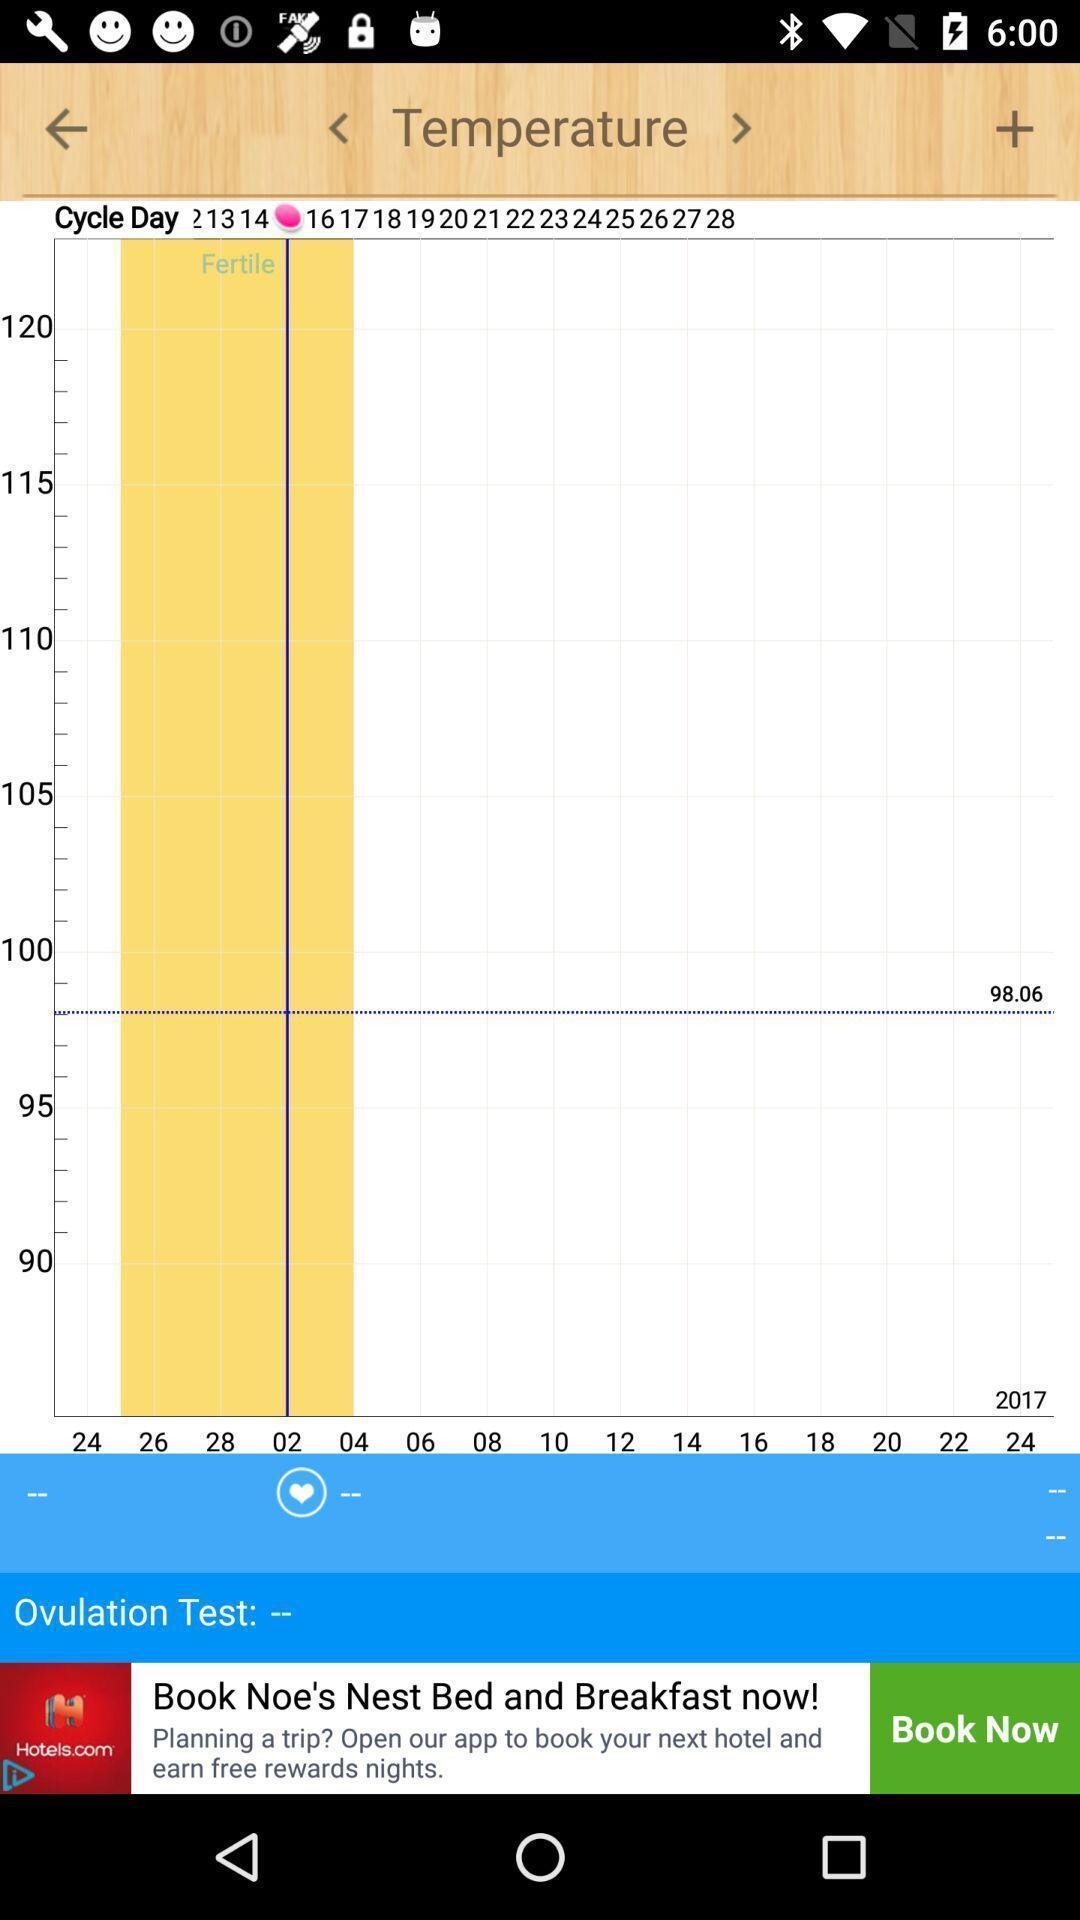Tell me about the visual elements in this screen capture. Screen shows temperature graph. 